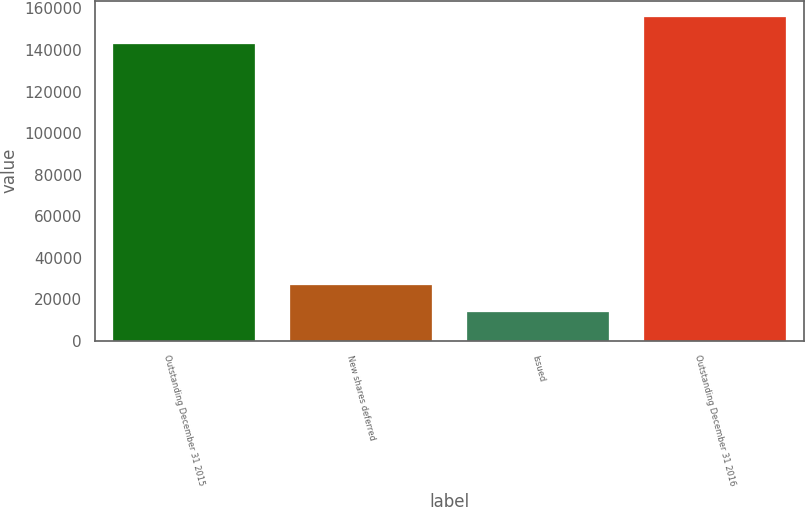Convert chart. <chart><loc_0><loc_0><loc_500><loc_500><bar_chart><fcel>Outstanding December 31 2015<fcel>New shares deferred<fcel>Issued<fcel>Outstanding December 31 2016<nl><fcel>142913<fcel>26592.8<fcel>13587<fcel>155919<nl></chart> 